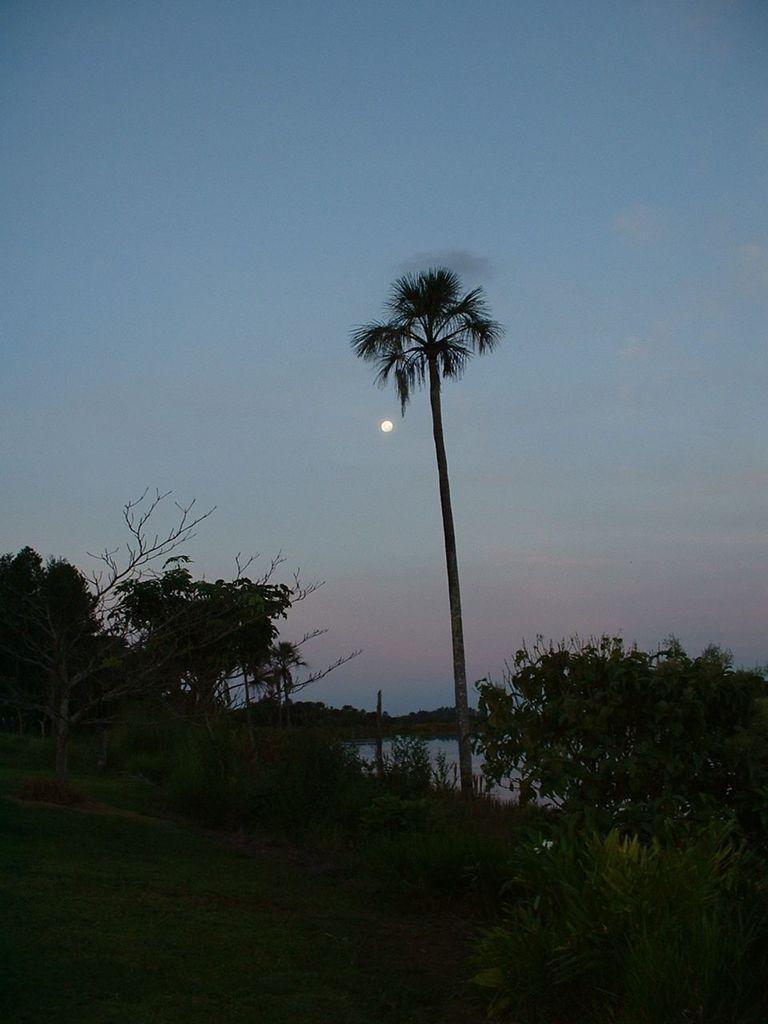Describe this image in one or two sentences. In this image in the center there is grass on the ground and there are plants. In the background there are trees and the sky is cloudy and there is a moon visible in the sky. 